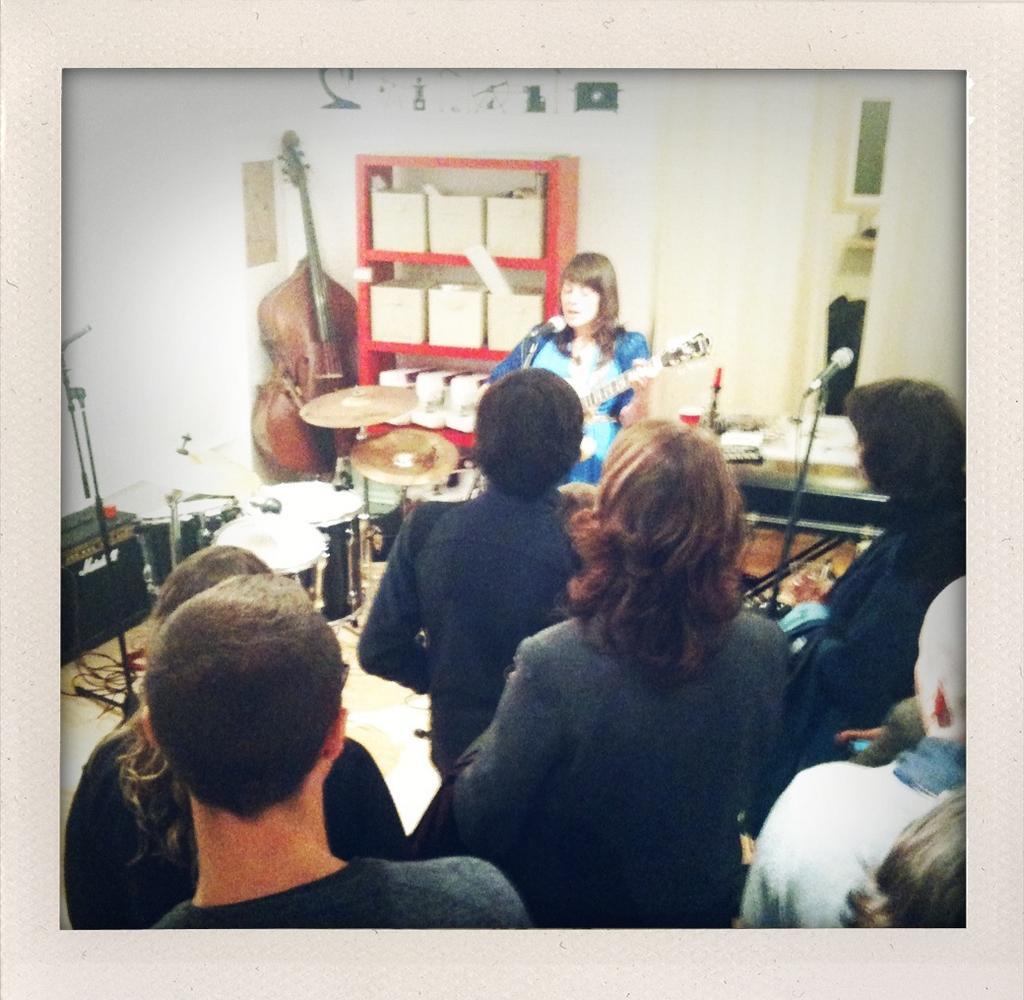Describe this image in one or two sentences. In this image we can see people and there is a woman playing guitar. Here we can see musical instruments, mike's, rack, and few objects. In the background we can see wall. 